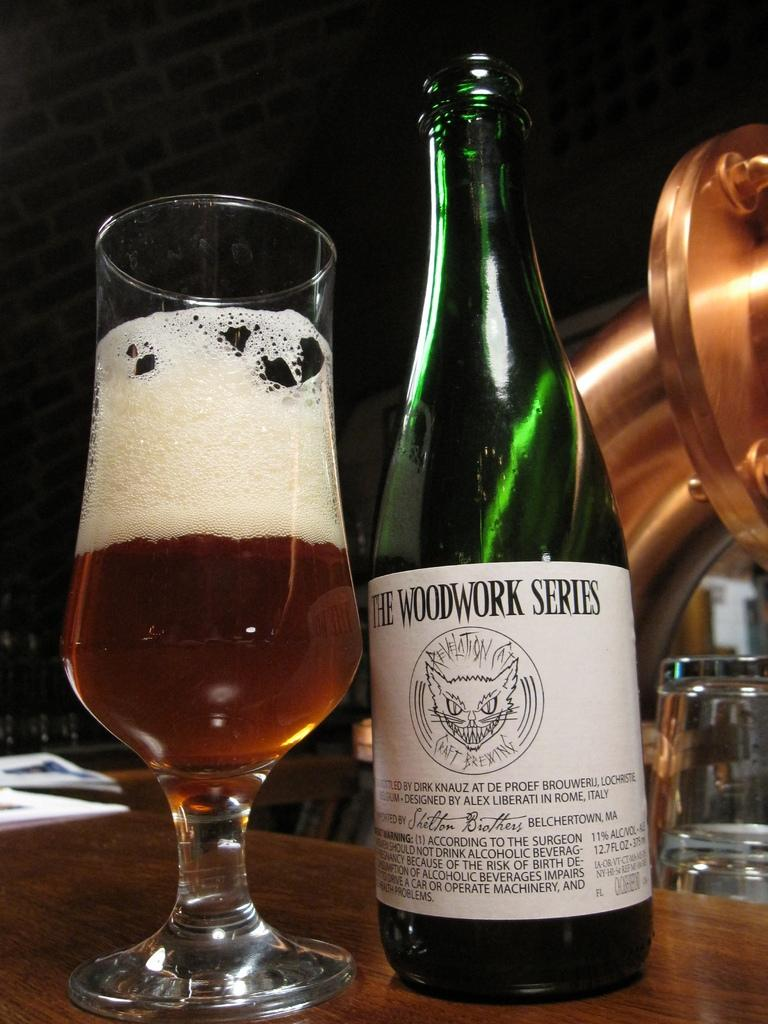<image>
Share a concise interpretation of the image provided. An open ale bottle of The Woodwork Series next to a half full glass. 